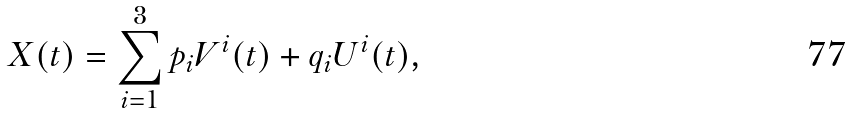Convert formula to latex. <formula><loc_0><loc_0><loc_500><loc_500>X ( t ) = \sum _ { i = 1 } ^ { 3 } p _ { i } V ^ { i } ( t ) + q _ { i } U ^ { i } ( t ) ,</formula> 